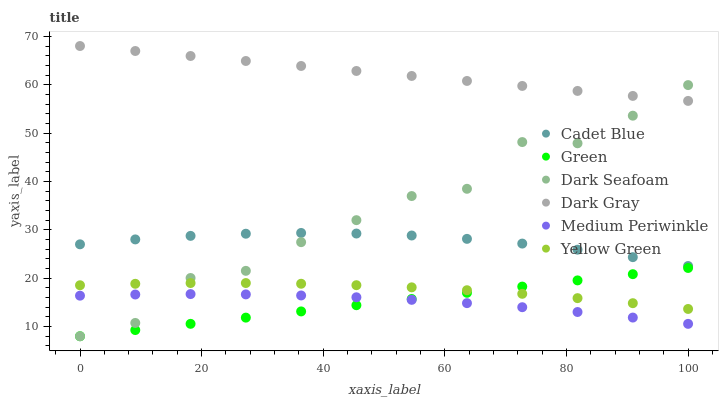Does Medium Periwinkle have the minimum area under the curve?
Answer yes or no. Yes. Does Dark Gray have the maximum area under the curve?
Answer yes or no. Yes. Does Yellow Green have the minimum area under the curve?
Answer yes or no. No. Does Yellow Green have the maximum area under the curve?
Answer yes or no. No. Is Green the smoothest?
Answer yes or no. Yes. Is Dark Seafoam the roughest?
Answer yes or no. Yes. Is Yellow Green the smoothest?
Answer yes or no. No. Is Yellow Green the roughest?
Answer yes or no. No. Does Dark Seafoam have the lowest value?
Answer yes or no. Yes. Does Yellow Green have the lowest value?
Answer yes or no. No. Does Dark Gray have the highest value?
Answer yes or no. Yes. Does Yellow Green have the highest value?
Answer yes or no. No. Is Green less than Dark Gray?
Answer yes or no. Yes. Is Dark Gray greater than Medium Periwinkle?
Answer yes or no. Yes. Does Dark Seafoam intersect Medium Periwinkle?
Answer yes or no. Yes. Is Dark Seafoam less than Medium Periwinkle?
Answer yes or no. No. Is Dark Seafoam greater than Medium Periwinkle?
Answer yes or no. No. Does Green intersect Dark Gray?
Answer yes or no. No. 